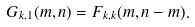<formula> <loc_0><loc_0><loc_500><loc_500>G _ { k , 1 } ( m , n ) = F _ { k , k } ( m , n - m ) .</formula> 